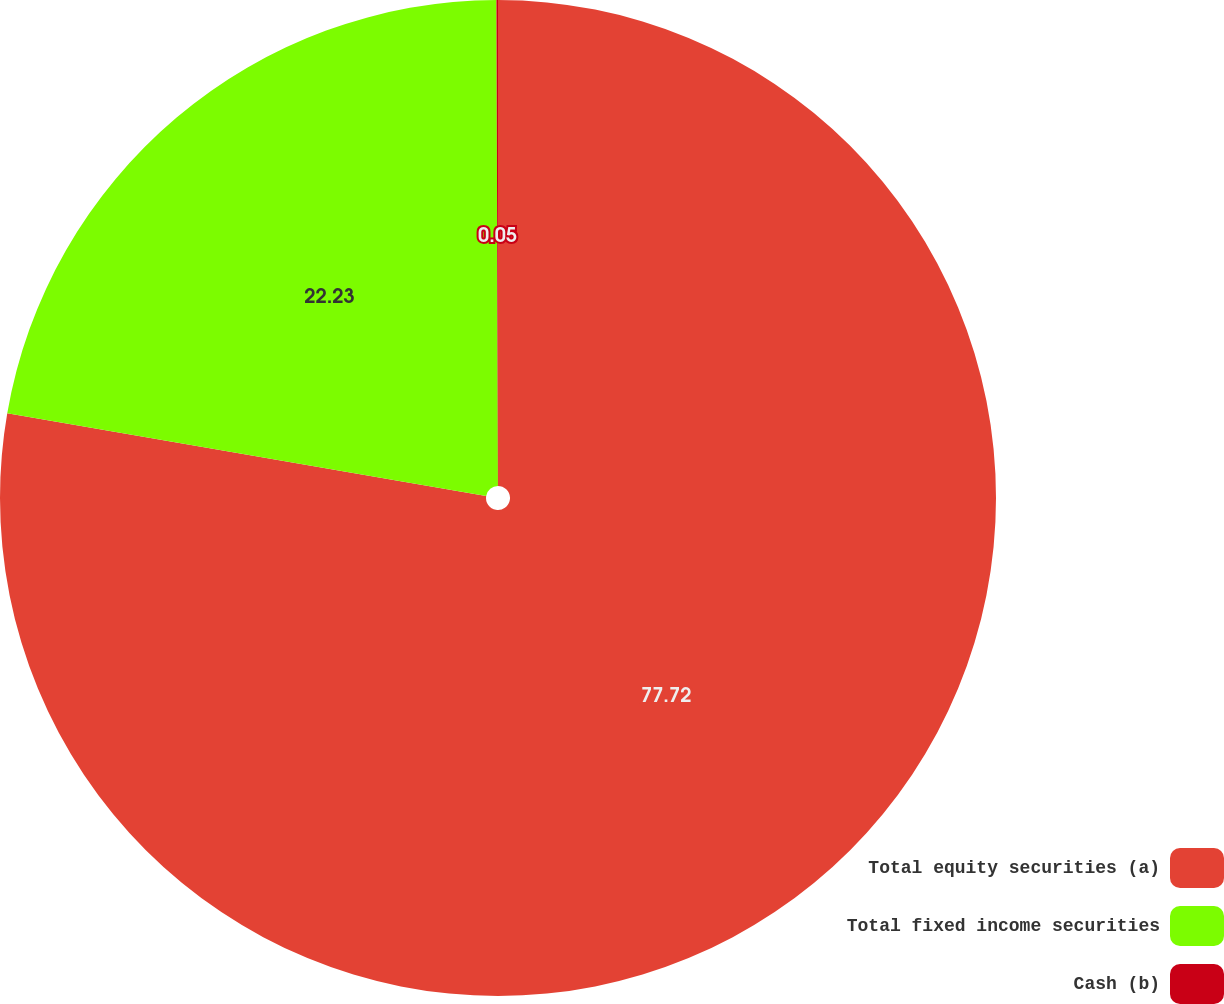Convert chart to OTSL. <chart><loc_0><loc_0><loc_500><loc_500><pie_chart><fcel>Total equity securities (a)<fcel>Total fixed income securities<fcel>Cash (b)<nl><fcel>77.72%<fcel>22.23%<fcel>0.05%<nl></chart> 